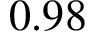<formula> <loc_0><loc_0><loc_500><loc_500>0 . 9 8</formula> 